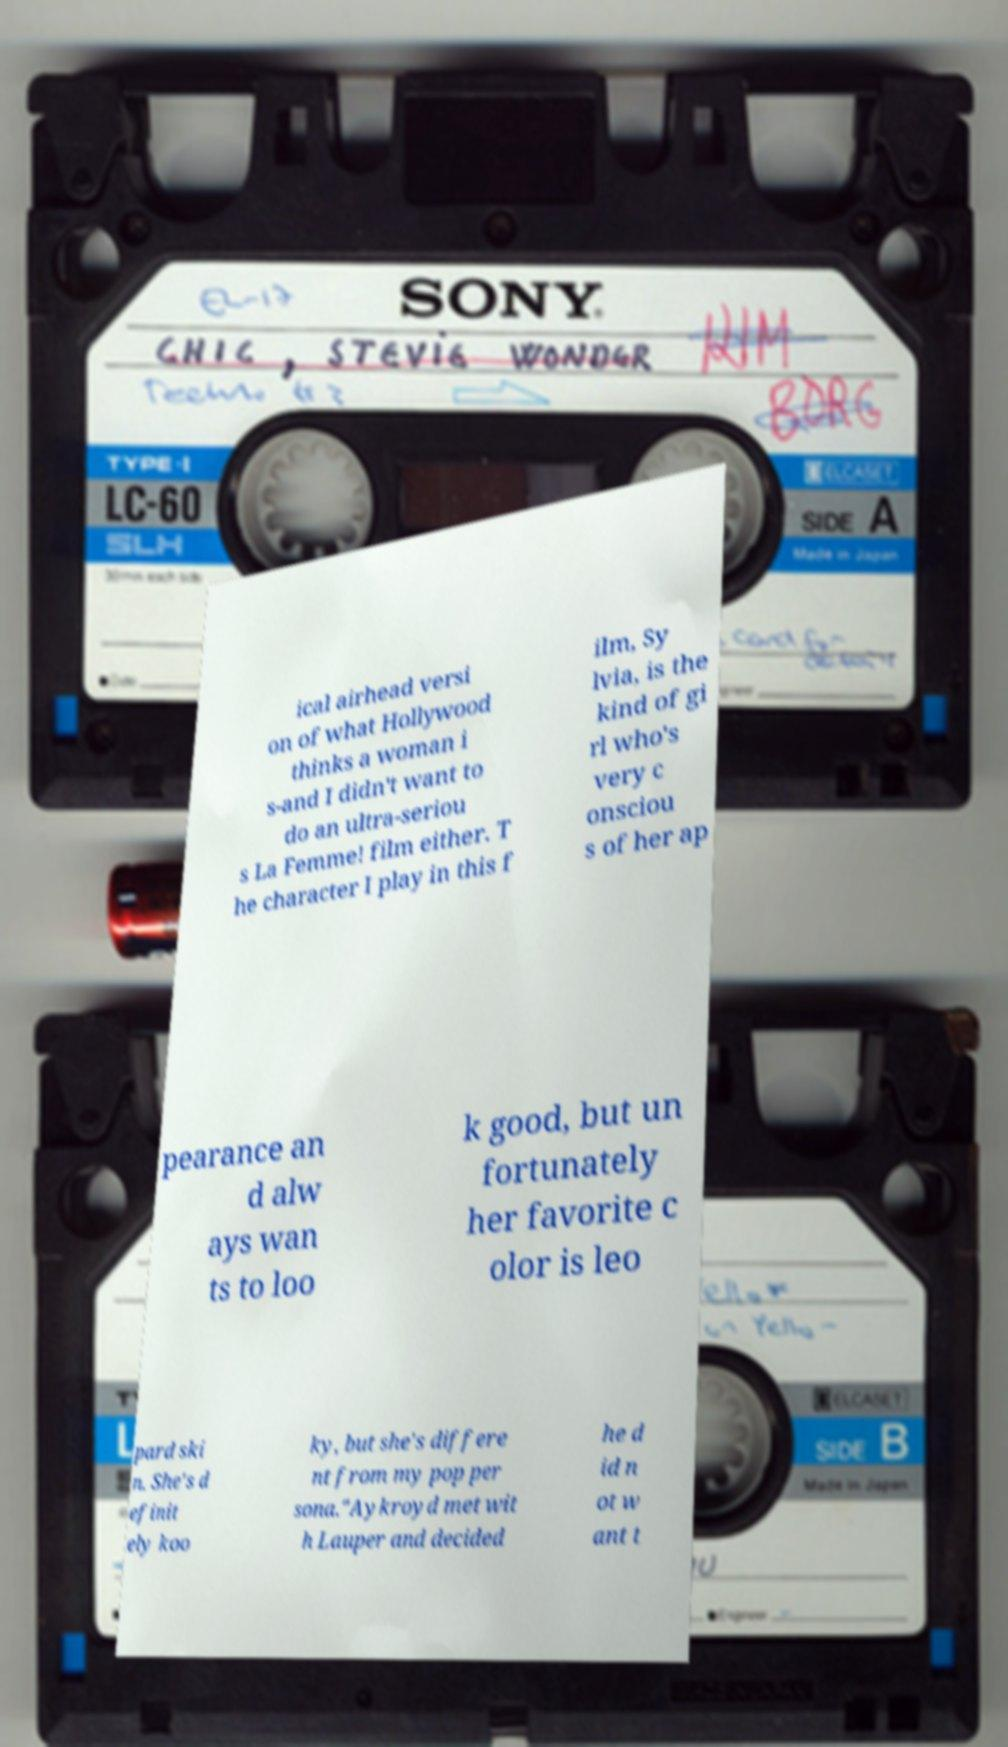There's text embedded in this image that I need extracted. Can you transcribe it verbatim? ical airhead versi on of what Hollywood thinks a woman i s-and I didn't want to do an ultra-seriou s La Femme! film either. T he character I play in this f ilm, Sy lvia, is the kind of gi rl who's very c onsciou s of her ap pearance an d alw ays wan ts to loo k good, but un fortunately her favorite c olor is leo pard ski n. She's d efinit ely koo ky, but she's differe nt from my pop per sona."Aykroyd met wit h Lauper and decided he d id n ot w ant t 